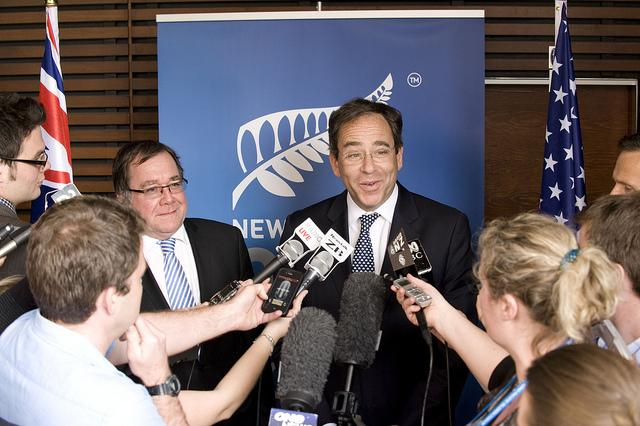Why are the people holding microphones? reporters 